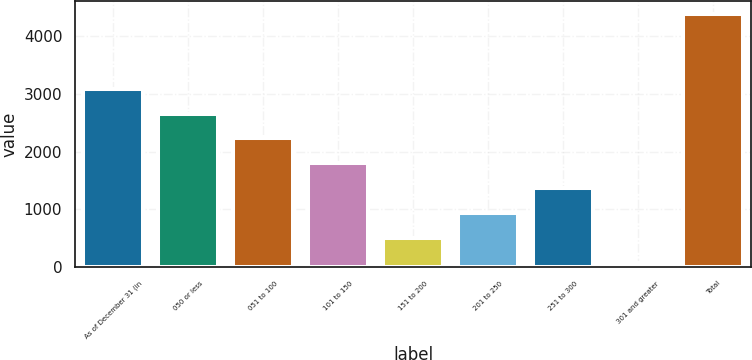Convert chart. <chart><loc_0><loc_0><loc_500><loc_500><bar_chart><fcel>As of December 31 (in<fcel>050 or less<fcel>051 to 100<fcel>101 to 150<fcel>151 to 200<fcel>201 to 250<fcel>251 to 300<fcel>301 and greater<fcel>Total<nl><fcel>3088.7<fcel>2657.3<fcel>2225.9<fcel>1794.5<fcel>500.3<fcel>931.7<fcel>1363.1<fcel>68.9<fcel>4382.9<nl></chart> 